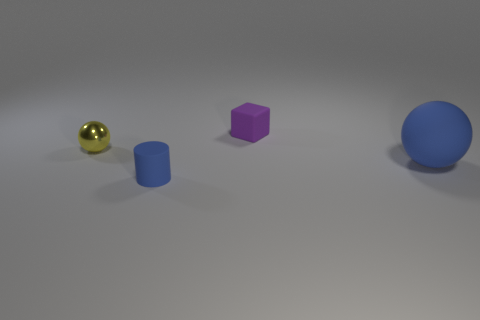Add 3 large green cylinders. How many objects exist? 7 Subtract all blocks. How many objects are left? 3 Subtract all purple cylinders. How many gray spheres are left? 0 Subtract all small balls. Subtract all blue matte cylinders. How many objects are left? 2 Add 3 tiny yellow shiny spheres. How many tiny yellow shiny spheres are left? 4 Add 2 balls. How many balls exist? 4 Subtract 0 red blocks. How many objects are left? 4 Subtract 1 cubes. How many cubes are left? 0 Subtract all gray balls. Subtract all gray cubes. How many balls are left? 2 